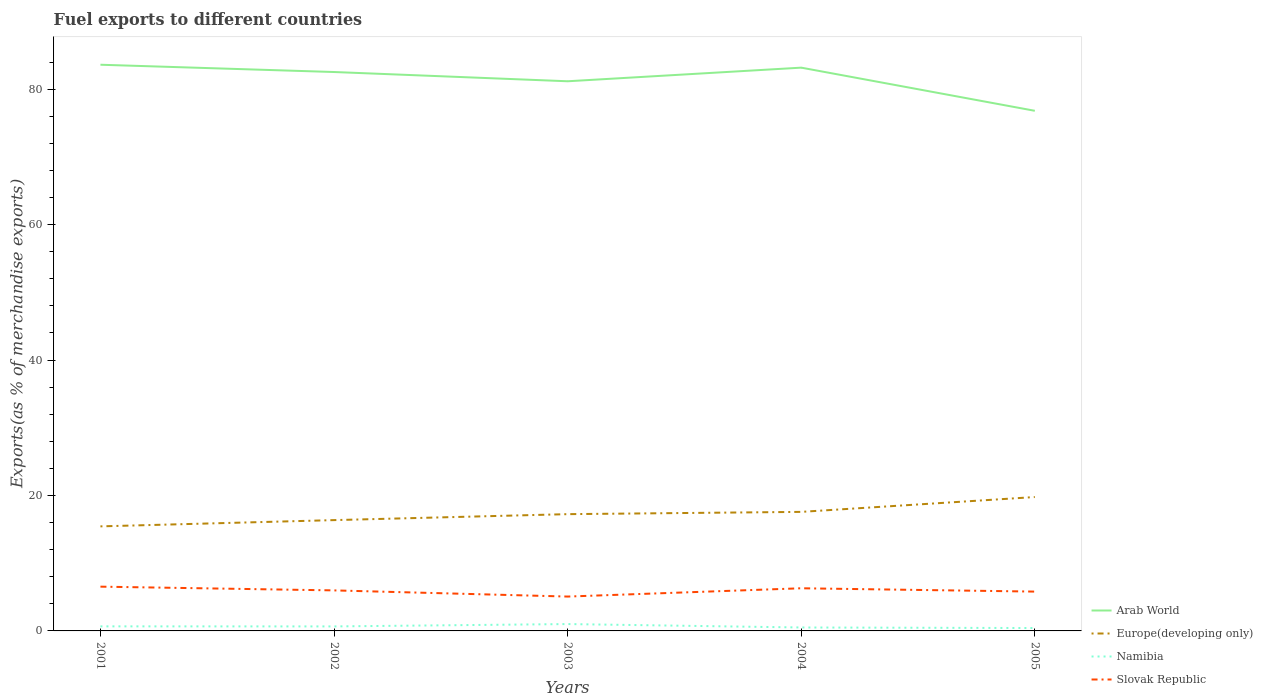Does the line corresponding to Namibia intersect with the line corresponding to Europe(developing only)?
Provide a succinct answer. No. Is the number of lines equal to the number of legend labels?
Provide a short and direct response. Yes. Across all years, what is the maximum percentage of exports to different countries in Europe(developing only)?
Offer a terse response. 15.44. What is the total percentage of exports to different countries in Arab World in the graph?
Keep it short and to the point. 1.07. What is the difference between the highest and the second highest percentage of exports to different countries in Europe(developing only)?
Provide a short and direct response. 4.33. Is the percentage of exports to different countries in Slovak Republic strictly greater than the percentage of exports to different countries in Europe(developing only) over the years?
Provide a short and direct response. Yes. How many lines are there?
Ensure brevity in your answer.  4. What is the difference between two consecutive major ticks on the Y-axis?
Your answer should be compact. 20. Does the graph contain grids?
Make the answer very short. No. How many legend labels are there?
Offer a terse response. 4. What is the title of the graph?
Offer a terse response. Fuel exports to different countries. Does "Madagascar" appear as one of the legend labels in the graph?
Make the answer very short. No. What is the label or title of the Y-axis?
Your answer should be very brief. Exports(as % of merchandise exports). What is the Exports(as % of merchandise exports) in Arab World in 2001?
Provide a short and direct response. 83.6. What is the Exports(as % of merchandise exports) of Europe(developing only) in 2001?
Give a very brief answer. 15.44. What is the Exports(as % of merchandise exports) in Namibia in 2001?
Keep it short and to the point. 0.67. What is the Exports(as % of merchandise exports) of Slovak Republic in 2001?
Provide a succinct answer. 6.54. What is the Exports(as % of merchandise exports) of Arab World in 2002?
Provide a short and direct response. 82.53. What is the Exports(as % of merchandise exports) of Europe(developing only) in 2002?
Offer a very short reply. 16.36. What is the Exports(as % of merchandise exports) in Namibia in 2002?
Make the answer very short. 0.67. What is the Exports(as % of merchandise exports) in Slovak Republic in 2002?
Offer a terse response. 5.98. What is the Exports(as % of merchandise exports) of Arab World in 2003?
Provide a short and direct response. 81.16. What is the Exports(as % of merchandise exports) in Europe(developing only) in 2003?
Keep it short and to the point. 17.24. What is the Exports(as % of merchandise exports) of Namibia in 2003?
Give a very brief answer. 1.01. What is the Exports(as % of merchandise exports) of Slovak Republic in 2003?
Provide a succinct answer. 5.07. What is the Exports(as % of merchandise exports) in Arab World in 2004?
Your response must be concise. 83.17. What is the Exports(as % of merchandise exports) of Europe(developing only) in 2004?
Give a very brief answer. 17.58. What is the Exports(as % of merchandise exports) in Namibia in 2004?
Give a very brief answer. 0.51. What is the Exports(as % of merchandise exports) of Slovak Republic in 2004?
Your answer should be compact. 6.3. What is the Exports(as % of merchandise exports) in Arab World in 2005?
Give a very brief answer. 76.8. What is the Exports(as % of merchandise exports) of Europe(developing only) in 2005?
Provide a short and direct response. 19.77. What is the Exports(as % of merchandise exports) in Namibia in 2005?
Provide a succinct answer. 0.43. What is the Exports(as % of merchandise exports) in Slovak Republic in 2005?
Keep it short and to the point. 5.81. Across all years, what is the maximum Exports(as % of merchandise exports) in Arab World?
Offer a very short reply. 83.6. Across all years, what is the maximum Exports(as % of merchandise exports) in Europe(developing only)?
Provide a short and direct response. 19.77. Across all years, what is the maximum Exports(as % of merchandise exports) of Namibia?
Give a very brief answer. 1.01. Across all years, what is the maximum Exports(as % of merchandise exports) of Slovak Republic?
Offer a very short reply. 6.54. Across all years, what is the minimum Exports(as % of merchandise exports) of Arab World?
Give a very brief answer. 76.8. Across all years, what is the minimum Exports(as % of merchandise exports) of Europe(developing only)?
Keep it short and to the point. 15.44. Across all years, what is the minimum Exports(as % of merchandise exports) of Namibia?
Make the answer very short. 0.43. Across all years, what is the minimum Exports(as % of merchandise exports) of Slovak Republic?
Provide a succinct answer. 5.07. What is the total Exports(as % of merchandise exports) of Arab World in the graph?
Give a very brief answer. 407.27. What is the total Exports(as % of merchandise exports) of Europe(developing only) in the graph?
Ensure brevity in your answer.  86.39. What is the total Exports(as % of merchandise exports) in Namibia in the graph?
Ensure brevity in your answer.  3.29. What is the total Exports(as % of merchandise exports) in Slovak Republic in the graph?
Offer a terse response. 29.7. What is the difference between the Exports(as % of merchandise exports) of Arab World in 2001 and that in 2002?
Provide a short and direct response. 1.07. What is the difference between the Exports(as % of merchandise exports) of Europe(developing only) in 2001 and that in 2002?
Make the answer very short. -0.92. What is the difference between the Exports(as % of merchandise exports) of Namibia in 2001 and that in 2002?
Provide a succinct answer. 0.01. What is the difference between the Exports(as % of merchandise exports) of Slovak Republic in 2001 and that in 2002?
Offer a terse response. 0.55. What is the difference between the Exports(as % of merchandise exports) of Arab World in 2001 and that in 2003?
Give a very brief answer. 2.44. What is the difference between the Exports(as % of merchandise exports) of Europe(developing only) in 2001 and that in 2003?
Your answer should be very brief. -1.8. What is the difference between the Exports(as % of merchandise exports) in Namibia in 2001 and that in 2003?
Provide a short and direct response. -0.34. What is the difference between the Exports(as % of merchandise exports) in Slovak Republic in 2001 and that in 2003?
Offer a very short reply. 1.46. What is the difference between the Exports(as % of merchandise exports) in Arab World in 2001 and that in 2004?
Your response must be concise. 0.43. What is the difference between the Exports(as % of merchandise exports) in Europe(developing only) in 2001 and that in 2004?
Offer a terse response. -2.14. What is the difference between the Exports(as % of merchandise exports) in Namibia in 2001 and that in 2004?
Offer a terse response. 0.17. What is the difference between the Exports(as % of merchandise exports) in Slovak Republic in 2001 and that in 2004?
Keep it short and to the point. 0.24. What is the difference between the Exports(as % of merchandise exports) of Arab World in 2001 and that in 2005?
Your answer should be very brief. 6.8. What is the difference between the Exports(as % of merchandise exports) of Europe(developing only) in 2001 and that in 2005?
Offer a very short reply. -4.33. What is the difference between the Exports(as % of merchandise exports) in Namibia in 2001 and that in 2005?
Provide a short and direct response. 0.25. What is the difference between the Exports(as % of merchandise exports) in Slovak Republic in 2001 and that in 2005?
Offer a terse response. 0.73. What is the difference between the Exports(as % of merchandise exports) of Arab World in 2002 and that in 2003?
Offer a terse response. 1.37. What is the difference between the Exports(as % of merchandise exports) of Europe(developing only) in 2002 and that in 2003?
Your answer should be compact. -0.88. What is the difference between the Exports(as % of merchandise exports) in Namibia in 2002 and that in 2003?
Your answer should be compact. -0.35. What is the difference between the Exports(as % of merchandise exports) in Slovak Republic in 2002 and that in 2003?
Provide a succinct answer. 0.91. What is the difference between the Exports(as % of merchandise exports) in Arab World in 2002 and that in 2004?
Your answer should be compact. -0.64. What is the difference between the Exports(as % of merchandise exports) in Europe(developing only) in 2002 and that in 2004?
Offer a terse response. -1.22. What is the difference between the Exports(as % of merchandise exports) in Namibia in 2002 and that in 2004?
Offer a very short reply. 0.16. What is the difference between the Exports(as % of merchandise exports) in Slovak Republic in 2002 and that in 2004?
Your response must be concise. -0.31. What is the difference between the Exports(as % of merchandise exports) in Arab World in 2002 and that in 2005?
Your response must be concise. 5.73. What is the difference between the Exports(as % of merchandise exports) in Europe(developing only) in 2002 and that in 2005?
Offer a terse response. -3.41. What is the difference between the Exports(as % of merchandise exports) of Namibia in 2002 and that in 2005?
Provide a succinct answer. 0.24. What is the difference between the Exports(as % of merchandise exports) of Slovak Republic in 2002 and that in 2005?
Your answer should be compact. 0.18. What is the difference between the Exports(as % of merchandise exports) of Arab World in 2003 and that in 2004?
Your response must be concise. -2.01. What is the difference between the Exports(as % of merchandise exports) in Europe(developing only) in 2003 and that in 2004?
Ensure brevity in your answer.  -0.34. What is the difference between the Exports(as % of merchandise exports) in Namibia in 2003 and that in 2004?
Ensure brevity in your answer.  0.51. What is the difference between the Exports(as % of merchandise exports) in Slovak Republic in 2003 and that in 2004?
Offer a very short reply. -1.22. What is the difference between the Exports(as % of merchandise exports) of Arab World in 2003 and that in 2005?
Ensure brevity in your answer.  4.36. What is the difference between the Exports(as % of merchandise exports) in Europe(developing only) in 2003 and that in 2005?
Provide a short and direct response. -2.53. What is the difference between the Exports(as % of merchandise exports) in Namibia in 2003 and that in 2005?
Provide a succinct answer. 0.59. What is the difference between the Exports(as % of merchandise exports) in Slovak Republic in 2003 and that in 2005?
Offer a very short reply. -0.73. What is the difference between the Exports(as % of merchandise exports) in Arab World in 2004 and that in 2005?
Provide a succinct answer. 6.37. What is the difference between the Exports(as % of merchandise exports) of Europe(developing only) in 2004 and that in 2005?
Your response must be concise. -2.19. What is the difference between the Exports(as % of merchandise exports) in Namibia in 2004 and that in 2005?
Your answer should be very brief. 0.08. What is the difference between the Exports(as % of merchandise exports) in Slovak Republic in 2004 and that in 2005?
Keep it short and to the point. 0.49. What is the difference between the Exports(as % of merchandise exports) of Arab World in 2001 and the Exports(as % of merchandise exports) of Europe(developing only) in 2002?
Provide a succinct answer. 67.24. What is the difference between the Exports(as % of merchandise exports) of Arab World in 2001 and the Exports(as % of merchandise exports) of Namibia in 2002?
Keep it short and to the point. 82.94. What is the difference between the Exports(as % of merchandise exports) of Arab World in 2001 and the Exports(as % of merchandise exports) of Slovak Republic in 2002?
Keep it short and to the point. 77.62. What is the difference between the Exports(as % of merchandise exports) of Europe(developing only) in 2001 and the Exports(as % of merchandise exports) of Namibia in 2002?
Make the answer very short. 14.77. What is the difference between the Exports(as % of merchandise exports) of Europe(developing only) in 2001 and the Exports(as % of merchandise exports) of Slovak Republic in 2002?
Your answer should be very brief. 9.45. What is the difference between the Exports(as % of merchandise exports) in Namibia in 2001 and the Exports(as % of merchandise exports) in Slovak Republic in 2002?
Give a very brief answer. -5.31. What is the difference between the Exports(as % of merchandise exports) of Arab World in 2001 and the Exports(as % of merchandise exports) of Europe(developing only) in 2003?
Provide a succinct answer. 66.36. What is the difference between the Exports(as % of merchandise exports) of Arab World in 2001 and the Exports(as % of merchandise exports) of Namibia in 2003?
Make the answer very short. 82.59. What is the difference between the Exports(as % of merchandise exports) in Arab World in 2001 and the Exports(as % of merchandise exports) in Slovak Republic in 2003?
Make the answer very short. 78.53. What is the difference between the Exports(as % of merchandise exports) of Europe(developing only) in 2001 and the Exports(as % of merchandise exports) of Namibia in 2003?
Your answer should be very brief. 14.43. What is the difference between the Exports(as % of merchandise exports) of Europe(developing only) in 2001 and the Exports(as % of merchandise exports) of Slovak Republic in 2003?
Offer a terse response. 10.37. What is the difference between the Exports(as % of merchandise exports) of Namibia in 2001 and the Exports(as % of merchandise exports) of Slovak Republic in 2003?
Your response must be concise. -4.4. What is the difference between the Exports(as % of merchandise exports) in Arab World in 2001 and the Exports(as % of merchandise exports) in Europe(developing only) in 2004?
Provide a short and direct response. 66.02. What is the difference between the Exports(as % of merchandise exports) in Arab World in 2001 and the Exports(as % of merchandise exports) in Namibia in 2004?
Provide a succinct answer. 83.1. What is the difference between the Exports(as % of merchandise exports) in Arab World in 2001 and the Exports(as % of merchandise exports) in Slovak Republic in 2004?
Make the answer very short. 77.3. What is the difference between the Exports(as % of merchandise exports) of Europe(developing only) in 2001 and the Exports(as % of merchandise exports) of Namibia in 2004?
Offer a very short reply. 14.93. What is the difference between the Exports(as % of merchandise exports) in Europe(developing only) in 2001 and the Exports(as % of merchandise exports) in Slovak Republic in 2004?
Offer a very short reply. 9.14. What is the difference between the Exports(as % of merchandise exports) of Namibia in 2001 and the Exports(as % of merchandise exports) of Slovak Republic in 2004?
Ensure brevity in your answer.  -5.62. What is the difference between the Exports(as % of merchandise exports) of Arab World in 2001 and the Exports(as % of merchandise exports) of Europe(developing only) in 2005?
Keep it short and to the point. 63.83. What is the difference between the Exports(as % of merchandise exports) in Arab World in 2001 and the Exports(as % of merchandise exports) in Namibia in 2005?
Provide a short and direct response. 83.18. What is the difference between the Exports(as % of merchandise exports) of Arab World in 2001 and the Exports(as % of merchandise exports) of Slovak Republic in 2005?
Provide a short and direct response. 77.8. What is the difference between the Exports(as % of merchandise exports) of Europe(developing only) in 2001 and the Exports(as % of merchandise exports) of Namibia in 2005?
Your response must be concise. 15.01. What is the difference between the Exports(as % of merchandise exports) in Europe(developing only) in 2001 and the Exports(as % of merchandise exports) in Slovak Republic in 2005?
Your response must be concise. 9.63. What is the difference between the Exports(as % of merchandise exports) in Namibia in 2001 and the Exports(as % of merchandise exports) in Slovak Republic in 2005?
Your answer should be compact. -5.13. What is the difference between the Exports(as % of merchandise exports) in Arab World in 2002 and the Exports(as % of merchandise exports) in Europe(developing only) in 2003?
Make the answer very short. 65.29. What is the difference between the Exports(as % of merchandise exports) in Arab World in 2002 and the Exports(as % of merchandise exports) in Namibia in 2003?
Your answer should be compact. 81.52. What is the difference between the Exports(as % of merchandise exports) of Arab World in 2002 and the Exports(as % of merchandise exports) of Slovak Republic in 2003?
Give a very brief answer. 77.46. What is the difference between the Exports(as % of merchandise exports) in Europe(developing only) in 2002 and the Exports(as % of merchandise exports) in Namibia in 2003?
Provide a succinct answer. 15.35. What is the difference between the Exports(as % of merchandise exports) in Europe(developing only) in 2002 and the Exports(as % of merchandise exports) in Slovak Republic in 2003?
Provide a short and direct response. 11.29. What is the difference between the Exports(as % of merchandise exports) of Namibia in 2002 and the Exports(as % of merchandise exports) of Slovak Republic in 2003?
Offer a very short reply. -4.41. What is the difference between the Exports(as % of merchandise exports) in Arab World in 2002 and the Exports(as % of merchandise exports) in Europe(developing only) in 2004?
Provide a succinct answer. 64.95. What is the difference between the Exports(as % of merchandise exports) of Arab World in 2002 and the Exports(as % of merchandise exports) of Namibia in 2004?
Your response must be concise. 82.02. What is the difference between the Exports(as % of merchandise exports) of Arab World in 2002 and the Exports(as % of merchandise exports) of Slovak Republic in 2004?
Provide a short and direct response. 76.23. What is the difference between the Exports(as % of merchandise exports) in Europe(developing only) in 2002 and the Exports(as % of merchandise exports) in Namibia in 2004?
Your answer should be very brief. 15.86. What is the difference between the Exports(as % of merchandise exports) in Europe(developing only) in 2002 and the Exports(as % of merchandise exports) in Slovak Republic in 2004?
Your response must be concise. 10.06. What is the difference between the Exports(as % of merchandise exports) of Namibia in 2002 and the Exports(as % of merchandise exports) of Slovak Republic in 2004?
Offer a very short reply. -5.63. What is the difference between the Exports(as % of merchandise exports) in Arab World in 2002 and the Exports(as % of merchandise exports) in Europe(developing only) in 2005?
Give a very brief answer. 62.76. What is the difference between the Exports(as % of merchandise exports) of Arab World in 2002 and the Exports(as % of merchandise exports) of Namibia in 2005?
Keep it short and to the point. 82.1. What is the difference between the Exports(as % of merchandise exports) in Arab World in 2002 and the Exports(as % of merchandise exports) in Slovak Republic in 2005?
Provide a short and direct response. 76.72. What is the difference between the Exports(as % of merchandise exports) of Europe(developing only) in 2002 and the Exports(as % of merchandise exports) of Namibia in 2005?
Your answer should be very brief. 15.94. What is the difference between the Exports(as % of merchandise exports) of Europe(developing only) in 2002 and the Exports(as % of merchandise exports) of Slovak Republic in 2005?
Offer a terse response. 10.56. What is the difference between the Exports(as % of merchandise exports) in Namibia in 2002 and the Exports(as % of merchandise exports) in Slovak Republic in 2005?
Provide a succinct answer. -5.14. What is the difference between the Exports(as % of merchandise exports) of Arab World in 2003 and the Exports(as % of merchandise exports) of Europe(developing only) in 2004?
Your answer should be very brief. 63.58. What is the difference between the Exports(as % of merchandise exports) in Arab World in 2003 and the Exports(as % of merchandise exports) in Namibia in 2004?
Ensure brevity in your answer.  80.66. What is the difference between the Exports(as % of merchandise exports) in Arab World in 2003 and the Exports(as % of merchandise exports) in Slovak Republic in 2004?
Make the answer very short. 74.86. What is the difference between the Exports(as % of merchandise exports) in Europe(developing only) in 2003 and the Exports(as % of merchandise exports) in Namibia in 2004?
Your answer should be very brief. 16.74. What is the difference between the Exports(as % of merchandise exports) in Europe(developing only) in 2003 and the Exports(as % of merchandise exports) in Slovak Republic in 2004?
Ensure brevity in your answer.  10.94. What is the difference between the Exports(as % of merchandise exports) of Namibia in 2003 and the Exports(as % of merchandise exports) of Slovak Republic in 2004?
Offer a very short reply. -5.28. What is the difference between the Exports(as % of merchandise exports) in Arab World in 2003 and the Exports(as % of merchandise exports) in Europe(developing only) in 2005?
Your response must be concise. 61.39. What is the difference between the Exports(as % of merchandise exports) in Arab World in 2003 and the Exports(as % of merchandise exports) in Namibia in 2005?
Your response must be concise. 80.74. What is the difference between the Exports(as % of merchandise exports) of Arab World in 2003 and the Exports(as % of merchandise exports) of Slovak Republic in 2005?
Your answer should be compact. 75.36. What is the difference between the Exports(as % of merchandise exports) in Europe(developing only) in 2003 and the Exports(as % of merchandise exports) in Namibia in 2005?
Give a very brief answer. 16.82. What is the difference between the Exports(as % of merchandise exports) of Europe(developing only) in 2003 and the Exports(as % of merchandise exports) of Slovak Republic in 2005?
Make the answer very short. 11.44. What is the difference between the Exports(as % of merchandise exports) of Namibia in 2003 and the Exports(as % of merchandise exports) of Slovak Republic in 2005?
Provide a short and direct response. -4.79. What is the difference between the Exports(as % of merchandise exports) in Arab World in 2004 and the Exports(as % of merchandise exports) in Europe(developing only) in 2005?
Make the answer very short. 63.4. What is the difference between the Exports(as % of merchandise exports) of Arab World in 2004 and the Exports(as % of merchandise exports) of Namibia in 2005?
Provide a short and direct response. 82.75. What is the difference between the Exports(as % of merchandise exports) in Arab World in 2004 and the Exports(as % of merchandise exports) in Slovak Republic in 2005?
Your answer should be compact. 77.37. What is the difference between the Exports(as % of merchandise exports) in Europe(developing only) in 2004 and the Exports(as % of merchandise exports) in Namibia in 2005?
Your answer should be very brief. 17.15. What is the difference between the Exports(as % of merchandise exports) in Europe(developing only) in 2004 and the Exports(as % of merchandise exports) in Slovak Republic in 2005?
Provide a short and direct response. 11.77. What is the difference between the Exports(as % of merchandise exports) in Namibia in 2004 and the Exports(as % of merchandise exports) in Slovak Republic in 2005?
Keep it short and to the point. -5.3. What is the average Exports(as % of merchandise exports) in Arab World per year?
Provide a succinct answer. 81.45. What is the average Exports(as % of merchandise exports) in Europe(developing only) per year?
Give a very brief answer. 17.28. What is the average Exports(as % of merchandise exports) in Namibia per year?
Provide a succinct answer. 0.66. What is the average Exports(as % of merchandise exports) in Slovak Republic per year?
Provide a short and direct response. 5.94. In the year 2001, what is the difference between the Exports(as % of merchandise exports) in Arab World and Exports(as % of merchandise exports) in Europe(developing only)?
Provide a short and direct response. 68.16. In the year 2001, what is the difference between the Exports(as % of merchandise exports) of Arab World and Exports(as % of merchandise exports) of Namibia?
Offer a very short reply. 82.93. In the year 2001, what is the difference between the Exports(as % of merchandise exports) in Arab World and Exports(as % of merchandise exports) in Slovak Republic?
Offer a terse response. 77.07. In the year 2001, what is the difference between the Exports(as % of merchandise exports) of Europe(developing only) and Exports(as % of merchandise exports) of Namibia?
Provide a succinct answer. 14.76. In the year 2001, what is the difference between the Exports(as % of merchandise exports) in Europe(developing only) and Exports(as % of merchandise exports) in Slovak Republic?
Your answer should be compact. 8.9. In the year 2001, what is the difference between the Exports(as % of merchandise exports) in Namibia and Exports(as % of merchandise exports) in Slovak Republic?
Your answer should be compact. -5.86. In the year 2002, what is the difference between the Exports(as % of merchandise exports) in Arab World and Exports(as % of merchandise exports) in Europe(developing only)?
Your answer should be very brief. 66.17. In the year 2002, what is the difference between the Exports(as % of merchandise exports) of Arab World and Exports(as % of merchandise exports) of Namibia?
Ensure brevity in your answer.  81.86. In the year 2002, what is the difference between the Exports(as % of merchandise exports) in Arab World and Exports(as % of merchandise exports) in Slovak Republic?
Ensure brevity in your answer.  76.54. In the year 2002, what is the difference between the Exports(as % of merchandise exports) of Europe(developing only) and Exports(as % of merchandise exports) of Namibia?
Provide a short and direct response. 15.7. In the year 2002, what is the difference between the Exports(as % of merchandise exports) of Europe(developing only) and Exports(as % of merchandise exports) of Slovak Republic?
Ensure brevity in your answer.  10.38. In the year 2002, what is the difference between the Exports(as % of merchandise exports) of Namibia and Exports(as % of merchandise exports) of Slovak Republic?
Make the answer very short. -5.32. In the year 2003, what is the difference between the Exports(as % of merchandise exports) of Arab World and Exports(as % of merchandise exports) of Europe(developing only)?
Your answer should be compact. 63.92. In the year 2003, what is the difference between the Exports(as % of merchandise exports) of Arab World and Exports(as % of merchandise exports) of Namibia?
Keep it short and to the point. 80.15. In the year 2003, what is the difference between the Exports(as % of merchandise exports) of Arab World and Exports(as % of merchandise exports) of Slovak Republic?
Offer a terse response. 76.09. In the year 2003, what is the difference between the Exports(as % of merchandise exports) in Europe(developing only) and Exports(as % of merchandise exports) in Namibia?
Provide a short and direct response. 16.23. In the year 2003, what is the difference between the Exports(as % of merchandise exports) of Europe(developing only) and Exports(as % of merchandise exports) of Slovak Republic?
Your answer should be very brief. 12.17. In the year 2003, what is the difference between the Exports(as % of merchandise exports) in Namibia and Exports(as % of merchandise exports) in Slovak Republic?
Provide a succinct answer. -4.06. In the year 2004, what is the difference between the Exports(as % of merchandise exports) in Arab World and Exports(as % of merchandise exports) in Europe(developing only)?
Provide a succinct answer. 65.59. In the year 2004, what is the difference between the Exports(as % of merchandise exports) in Arab World and Exports(as % of merchandise exports) in Namibia?
Your answer should be very brief. 82.67. In the year 2004, what is the difference between the Exports(as % of merchandise exports) of Arab World and Exports(as % of merchandise exports) of Slovak Republic?
Provide a succinct answer. 76.88. In the year 2004, what is the difference between the Exports(as % of merchandise exports) of Europe(developing only) and Exports(as % of merchandise exports) of Namibia?
Make the answer very short. 17.07. In the year 2004, what is the difference between the Exports(as % of merchandise exports) of Europe(developing only) and Exports(as % of merchandise exports) of Slovak Republic?
Ensure brevity in your answer.  11.28. In the year 2004, what is the difference between the Exports(as % of merchandise exports) in Namibia and Exports(as % of merchandise exports) in Slovak Republic?
Give a very brief answer. -5.79. In the year 2005, what is the difference between the Exports(as % of merchandise exports) in Arab World and Exports(as % of merchandise exports) in Europe(developing only)?
Provide a short and direct response. 57.03. In the year 2005, what is the difference between the Exports(as % of merchandise exports) in Arab World and Exports(as % of merchandise exports) in Namibia?
Your answer should be compact. 76.38. In the year 2005, what is the difference between the Exports(as % of merchandise exports) in Arab World and Exports(as % of merchandise exports) in Slovak Republic?
Offer a very short reply. 70.99. In the year 2005, what is the difference between the Exports(as % of merchandise exports) of Europe(developing only) and Exports(as % of merchandise exports) of Namibia?
Your answer should be very brief. 19.34. In the year 2005, what is the difference between the Exports(as % of merchandise exports) in Europe(developing only) and Exports(as % of merchandise exports) in Slovak Republic?
Your response must be concise. 13.96. In the year 2005, what is the difference between the Exports(as % of merchandise exports) in Namibia and Exports(as % of merchandise exports) in Slovak Republic?
Offer a very short reply. -5.38. What is the ratio of the Exports(as % of merchandise exports) in Arab World in 2001 to that in 2002?
Your answer should be very brief. 1.01. What is the ratio of the Exports(as % of merchandise exports) in Europe(developing only) in 2001 to that in 2002?
Keep it short and to the point. 0.94. What is the ratio of the Exports(as % of merchandise exports) in Namibia in 2001 to that in 2002?
Make the answer very short. 1.01. What is the ratio of the Exports(as % of merchandise exports) in Slovak Republic in 2001 to that in 2002?
Ensure brevity in your answer.  1.09. What is the ratio of the Exports(as % of merchandise exports) of Arab World in 2001 to that in 2003?
Provide a succinct answer. 1.03. What is the ratio of the Exports(as % of merchandise exports) of Europe(developing only) in 2001 to that in 2003?
Provide a succinct answer. 0.9. What is the ratio of the Exports(as % of merchandise exports) of Namibia in 2001 to that in 2003?
Your answer should be compact. 0.67. What is the ratio of the Exports(as % of merchandise exports) of Slovak Republic in 2001 to that in 2003?
Ensure brevity in your answer.  1.29. What is the ratio of the Exports(as % of merchandise exports) in Europe(developing only) in 2001 to that in 2004?
Keep it short and to the point. 0.88. What is the ratio of the Exports(as % of merchandise exports) of Namibia in 2001 to that in 2004?
Your response must be concise. 1.33. What is the ratio of the Exports(as % of merchandise exports) in Slovak Republic in 2001 to that in 2004?
Offer a very short reply. 1.04. What is the ratio of the Exports(as % of merchandise exports) in Arab World in 2001 to that in 2005?
Your response must be concise. 1.09. What is the ratio of the Exports(as % of merchandise exports) in Europe(developing only) in 2001 to that in 2005?
Your answer should be compact. 0.78. What is the ratio of the Exports(as % of merchandise exports) in Namibia in 2001 to that in 2005?
Offer a terse response. 1.58. What is the ratio of the Exports(as % of merchandise exports) in Slovak Republic in 2001 to that in 2005?
Offer a very short reply. 1.13. What is the ratio of the Exports(as % of merchandise exports) in Arab World in 2002 to that in 2003?
Provide a succinct answer. 1.02. What is the ratio of the Exports(as % of merchandise exports) of Europe(developing only) in 2002 to that in 2003?
Offer a terse response. 0.95. What is the ratio of the Exports(as % of merchandise exports) of Namibia in 2002 to that in 2003?
Keep it short and to the point. 0.66. What is the ratio of the Exports(as % of merchandise exports) in Slovak Republic in 2002 to that in 2003?
Offer a terse response. 1.18. What is the ratio of the Exports(as % of merchandise exports) of Arab World in 2002 to that in 2004?
Provide a short and direct response. 0.99. What is the ratio of the Exports(as % of merchandise exports) in Europe(developing only) in 2002 to that in 2004?
Make the answer very short. 0.93. What is the ratio of the Exports(as % of merchandise exports) in Namibia in 2002 to that in 2004?
Keep it short and to the point. 1.31. What is the ratio of the Exports(as % of merchandise exports) in Slovak Republic in 2002 to that in 2004?
Keep it short and to the point. 0.95. What is the ratio of the Exports(as % of merchandise exports) in Arab World in 2002 to that in 2005?
Your answer should be compact. 1.07. What is the ratio of the Exports(as % of merchandise exports) of Europe(developing only) in 2002 to that in 2005?
Provide a short and direct response. 0.83. What is the ratio of the Exports(as % of merchandise exports) in Namibia in 2002 to that in 2005?
Your answer should be compact. 1.56. What is the ratio of the Exports(as % of merchandise exports) of Slovak Republic in 2002 to that in 2005?
Offer a very short reply. 1.03. What is the ratio of the Exports(as % of merchandise exports) in Arab World in 2003 to that in 2004?
Provide a short and direct response. 0.98. What is the ratio of the Exports(as % of merchandise exports) of Europe(developing only) in 2003 to that in 2004?
Provide a succinct answer. 0.98. What is the ratio of the Exports(as % of merchandise exports) in Namibia in 2003 to that in 2004?
Your answer should be very brief. 2. What is the ratio of the Exports(as % of merchandise exports) of Slovak Republic in 2003 to that in 2004?
Offer a very short reply. 0.81. What is the ratio of the Exports(as % of merchandise exports) of Arab World in 2003 to that in 2005?
Your answer should be compact. 1.06. What is the ratio of the Exports(as % of merchandise exports) of Europe(developing only) in 2003 to that in 2005?
Provide a short and direct response. 0.87. What is the ratio of the Exports(as % of merchandise exports) in Namibia in 2003 to that in 2005?
Keep it short and to the point. 2.38. What is the ratio of the Exports(as % of merchandise exports) in Slovak Republic in 2003 to that in 2005?
Your answer should be compact. 0.87. What is the ratio of the Exports(as % of merchandise exports) in Arab World in 2004 to that in 2005?
Ensure brevity in your answer.  1.08. What is the ratio of the Exports(as % of merchandise exports) in Europe(developing only) in 2004 to that in 2005?
Your answer should be compact. 0.89. What is the ratio of the Exports(as % of merchandise exports) in Namibia in 2004 to that in 2005?
Your answer should be compact. 1.19. What is the ratio of the Exports(as % of merchandise exports) in Slovak Republic in 2004 to that in 2005?
Offer a terse response. 1.08. What is the difference between the highest and the second highest Exports(as % of merchandise exports) in Arab World?
Ensure brevity in your answer.  0.43. What is the difference between the highest and the second highest Exports(as % of merchandise exports) in Europe(developing only)?
Provide a short and direct response. 2.19. What is the difference between the highest and the second highest Exports(as % of merchandise exports) in Namibia?
Your answer should be compact. 0.34. What is the difference between the highest and the second highest Exports(as % of merchandise exports) of Slovak Republic?
Give a very brief answer. 0.24. What is the difference between the highest and the lowest Exports(as % of merchandise exports) of Arab World?
Your answer should be very brief. 6.8. What is the difference between the highest and the lowest Exports(as % of merchandise exports) of Europe(developing only)?
Ensure brevity in your answer.  4.33. What is the difference between the highest and the lowest Exports(as % of merchandise exports) in Namibia?
Offer a terse response. 0.59. What is the difference between the highest and the lowest Exports(as % of merchandise exports) in Slovak Republic?
Make the answer very short. 1.46. 